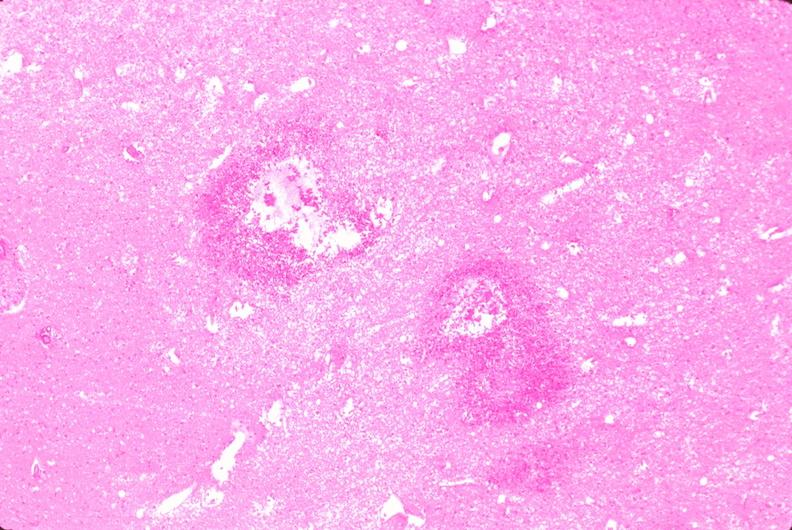what does this image show?
Answer the question using a single word or phrase. Brain 